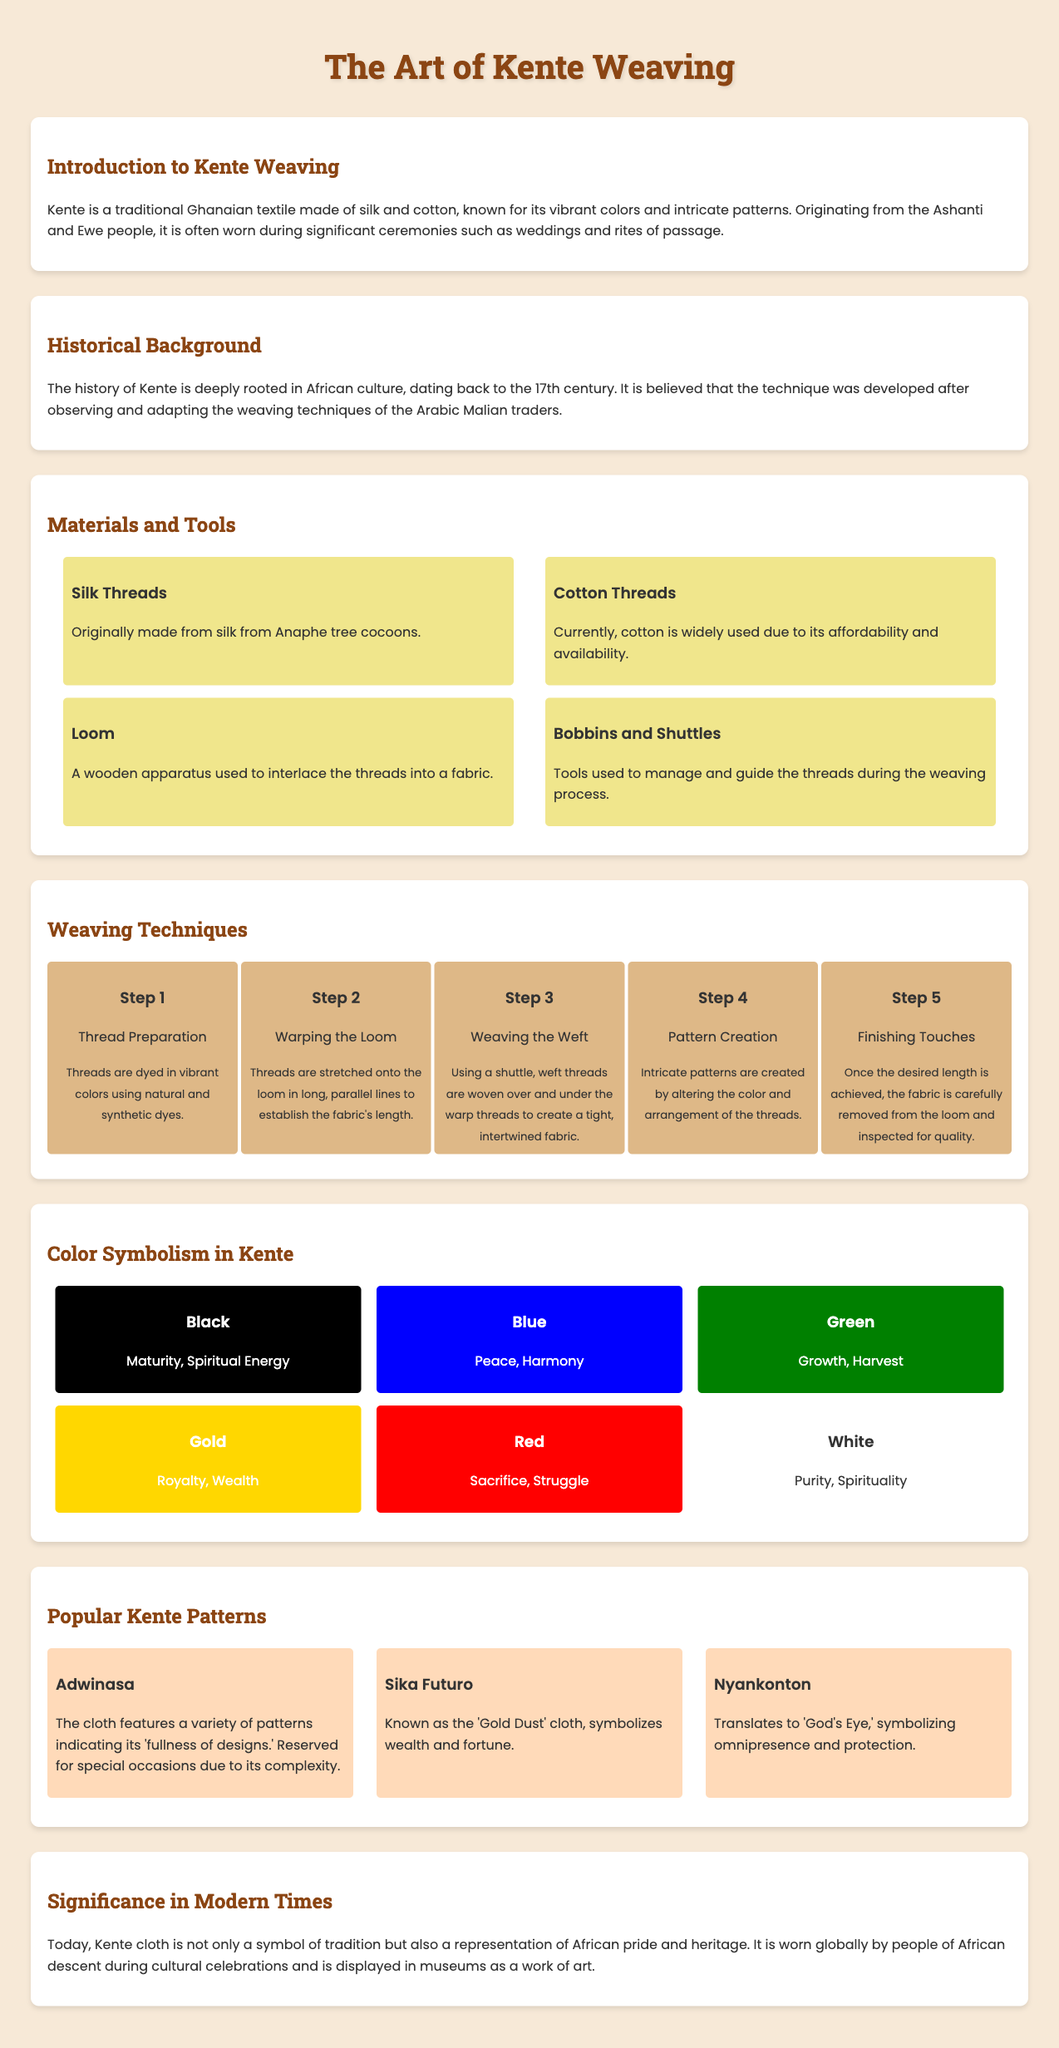What is the origin of Kente weaving? Kente weaving originates from the Ashanti and Ewe people of Ghana.
Answer: Ashanti and Ewe What year is Kente believed to have originated? The history of Kente dates back to the 17th century.
Answer: 17th century What materials are traditional Kente threads made of? Kente threads are originally made from silk and currently widely use cotton.
Answer: Silk and cotton What is the first step in the weaving process? The first step in the weaving process is thread preparation.
Answer: Thread preparation What does the color red symbolize in Kente weaving? The color red symbolizes sacrifice and struggle.
Answer: Sacrifice and struggle What is a characteristic of the Adwinasa pattern? The Adwinasa pattern indicates 'fullness of designs' and is reserved for special occasions due to complexity.
Answer: Fullness of designs What does the color blue represent in Kente? Blue represents peace and harmony.
Answer: Peace and harmony How many steps are in the Kente weaving process? There are five steps in the Kente weaving process.
Answer: Five What is the significance of Kente cloth in modern times? Kente cloth represents African pride and heritage, worn globally and displayed in museums.
Answer: African pride and heritage 